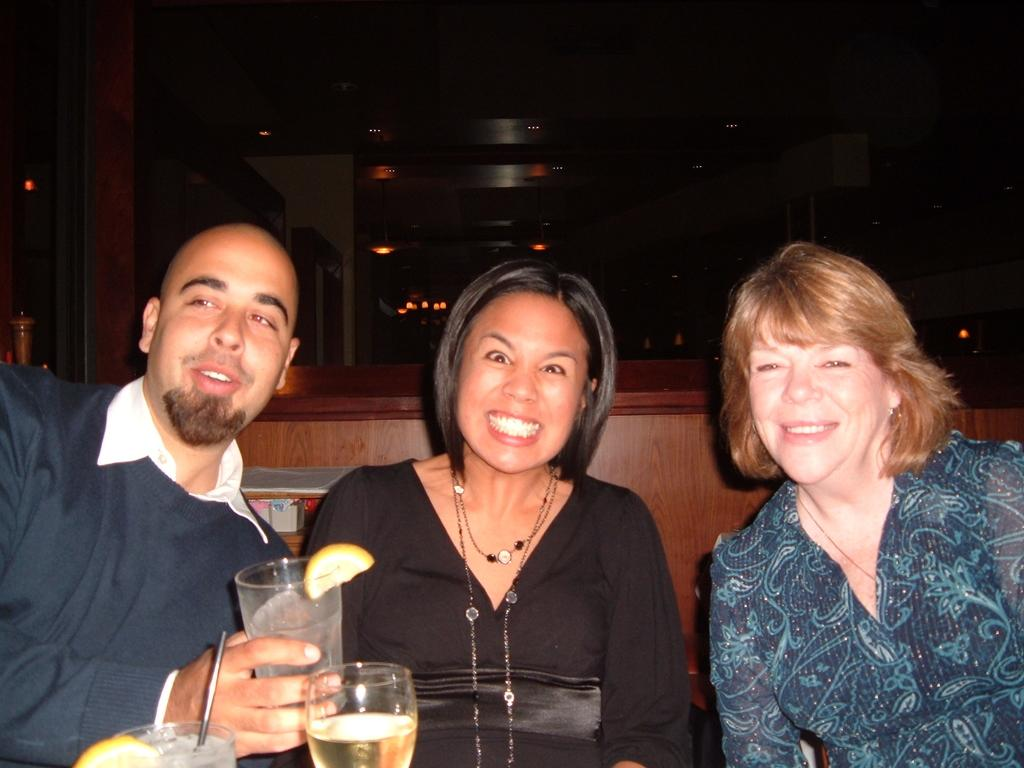What are the people in the image doing? The people in the image are sitting. What is one person holding in the image? One person is holding a glass. How many glasses can be seen in the image? There are glasses visible in the image. What type of feather can be seen on the person's statement in the image? There is no feather or statement present in the image. How many wounds can be seen on the person holding the glass in the image? There are no wounds visible on the person holding the glass in the image. 